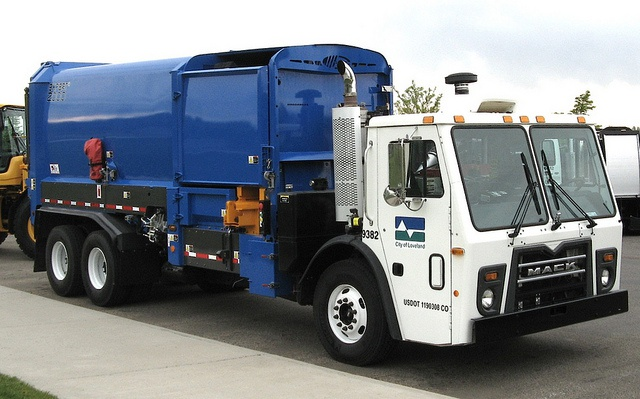Describe the objects in this image and their specific colors. I can see a truck in white, black, navy, and gray tones in this image. 